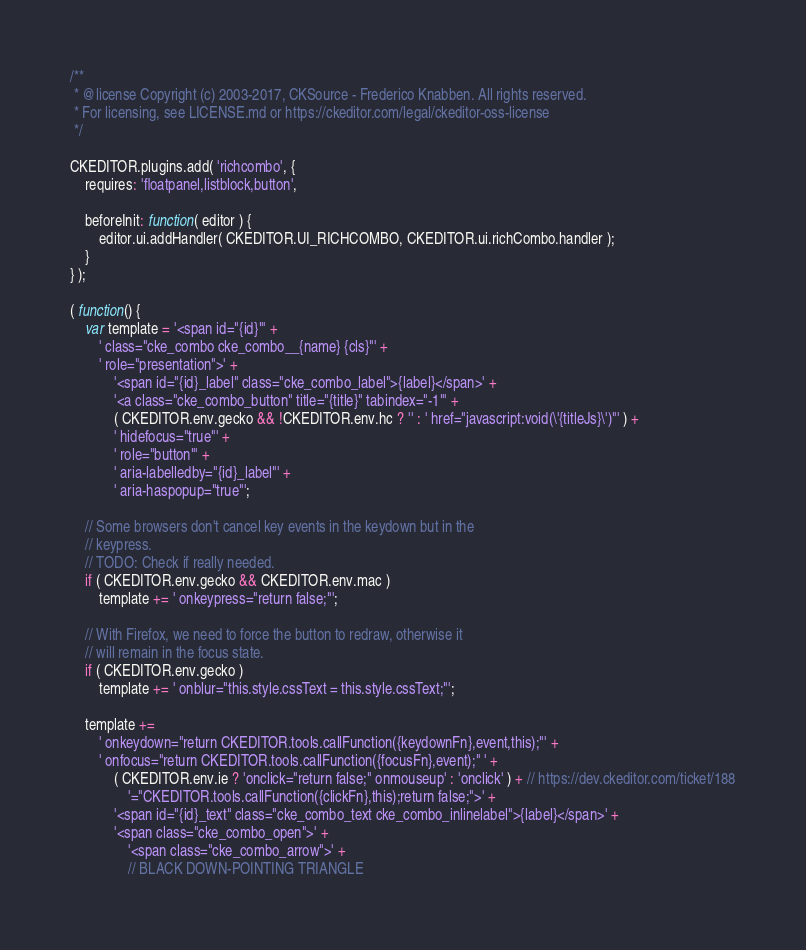<code> <loc_0><loc_0><loc_500><loc_500><_JavaScript_>/**
 * @license Copyright (c) 2003-2017, CKSource - Frederico Knabben. All rights reserved.
 * For licensing, see LICENSE.md or https://ckeditor.com/legal/ckeditor-oss-license
 */

CKEDITOR.plugins.add( 'richcombo', {
	requires: 'floatpanel,listblock,button',

	beforeInit: function( editor ) {
		editor.ui.addHandler( CKEDITOR.UI_RICHCOMBO, CKEDITOR.ui.richCombo.handler );
	}
} );

( function() {
	var template = '<span id="{id}"' +
		' class="cke_combo cke_combo__{name} {cls}"' +
		' role="presentation">' +
			'<span id="{id}_label" class="cke_combo_label">{label}</span>' +
			'<a class="cke_combo_button" title="{title}" tabindex="-1"' +
			( CKEDITOR.env.gecko && !CKEDITOR.env.hc ? '' : ' href="javascript:void(\'{titleJs}\')"' ) +
			' hidefocus="true"' +
			' role="button"' +
			' aria-labelledby="{id}_label"' +
			' aria-haspopup="true"';

	// Some browsers don't cancel key events in the keydown but in the
	// keypress.
	// TODO: Check if really needed.
	if ( CKEDITOR.env.gecko && CKEDITOR.env.mac )
		template += ' onkeypress="return false;"';

	// With Firefox, we need to force the button to redraw, otherwise it
	// will remain in the focus state.
	if ( CKEDITOR.env.gecko )
		template += ' onblur="this.style.cssText = this.style.cssText;"';

	template +=
		' onkeydown="return CKEDITOR.tools.callFunction({keydownFn},event,this);"' +
		' onfocus="return CKEDITOR.tools.callFunction({focusFn},event);" ' +
			( CKEDITOR.env.ie ? 'onclick="return false;" onmouseup' : 'onclick' ) + // https://dev.ckeditor.com/ticket/188
				'="CKEDITOR.tools.callFunction({clickFn},this);return false;">' +
			'<span id="{id}_text" class="cke_combo_text cke_combo_inlinelabel">{label}</span>' +
			'<span class="cke_combo_open">' +
				'<span class="cke_combo_arrow">' +
				// BLACK DOWN-POINTING TRIANGLE</code> 